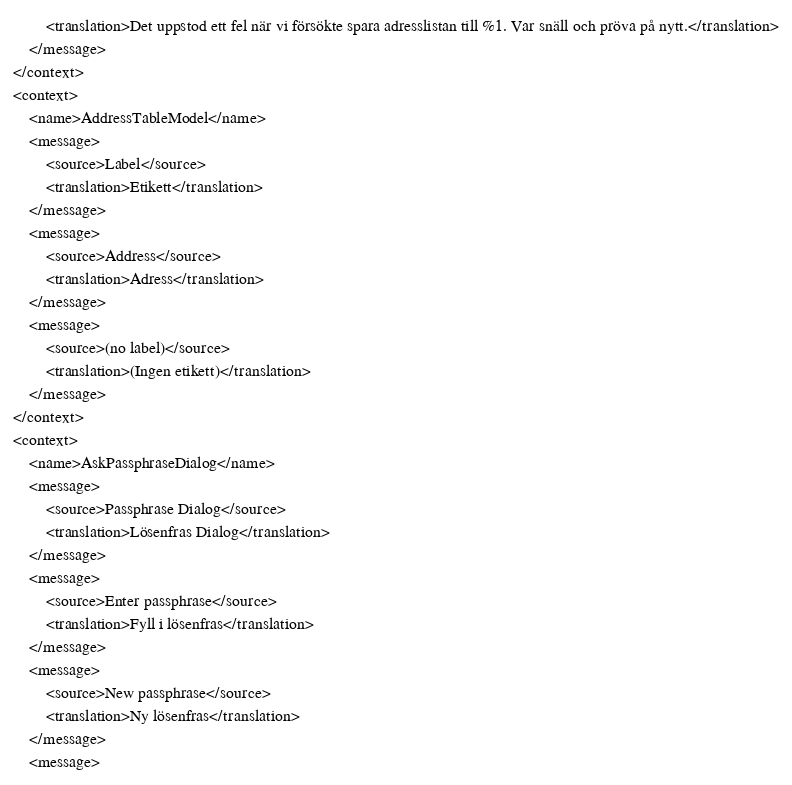<code> <loc_0><loc_0><loc_500><loc_500><_TypeScript_>        <translation>Det uppstod ett fel när vi försökte spara adresslistan till %1. Var snäll och pröva på nytt.</translation>
    </message>
</context>
<context>
    <name>AddressTableModel</name>
    <message>
        <source>Label</source>
        <translation>Etikett</translation>
    </message>
    <message>
        <source>Address</source>
        <translation>Adress</translation>
    </message>
    <message>
        <source>(no label)</source>
        <translation>(Ingen etikett)</translation>
    </message>
</context>
<context>
    <name>AskPassphraseDialog</name>
    <message>
        <source>Passphrase Dialog</source>
        <translation>Lösenfras Dialog</translation>
    </message>
    <message>
        <source>Enter passphrase</source>
        <translation>Fyll i lösenfras</translation>
    </message>
    <message>
        <source>New passphrase</source>
        <translation>Ny lösenfras</translation>
    </message>
    <message></code> 